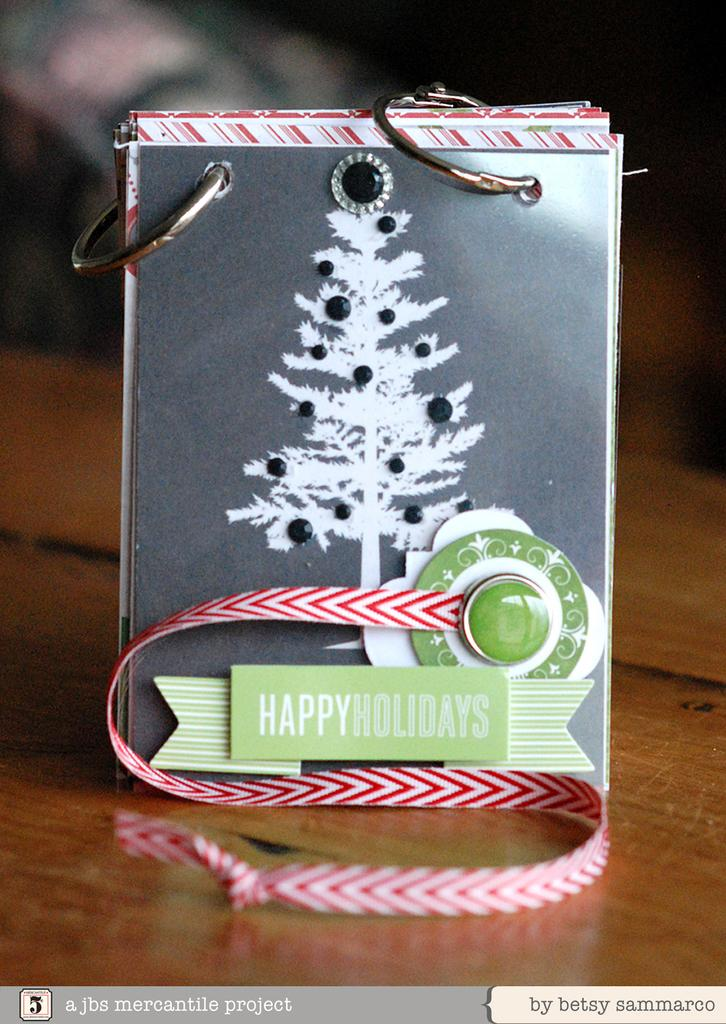What is the main subject of the image? The main subject of the image is a board with decorative items. What is the material of the board? The board has a wooden surface. What is depicted on the board? There is a tree depicted on the board. What is the color of the background in the image? The background of the image is dark. What can be found at the bottom of the image? There is text at the bottom of the image. How many toes are visible on the tree in the image? There are no toes visible in the image, as it features a board with a tree depicted on it, not an actual tree. 